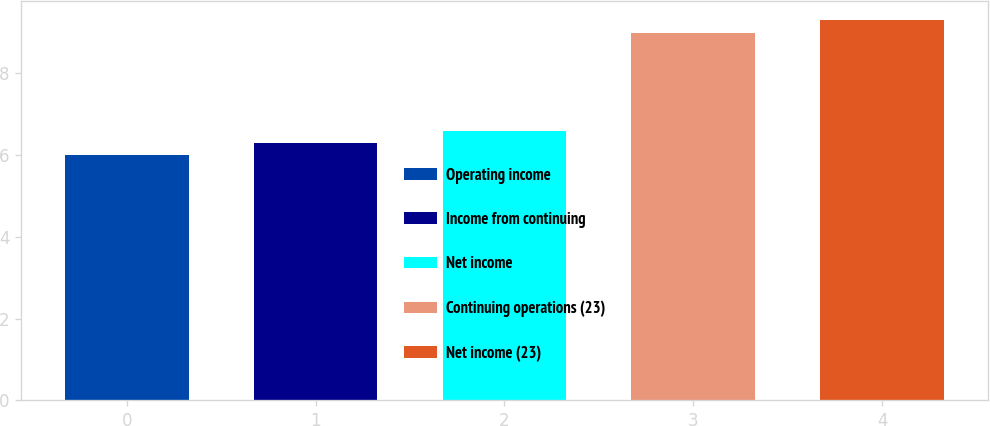Convert chart to OTSL. <chart><loc_0><loc_0><loc_500><loc_500><bar_chart><fcel>Operating income<fcel>Income from continuing<fcel>Net income<fcel>Continuing operations (23)<fcel>Net income (23)<nl><fcel>6<fcel>6.3<fcel>6.6<fcel>9<fcel>9.3<nl></chart> 